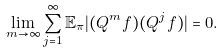Convert formula to latex. <formula><loc_0><loc_0><loc_500><loc_500>\lim _ { m \rightarrow \infty } \sum _ { j = 1 } ^ { \infty } \mathbb { E } _ { \pi } | ( Q ^ { m } f ) ( Q ^ { j } f ) | = 0 .</formula> 